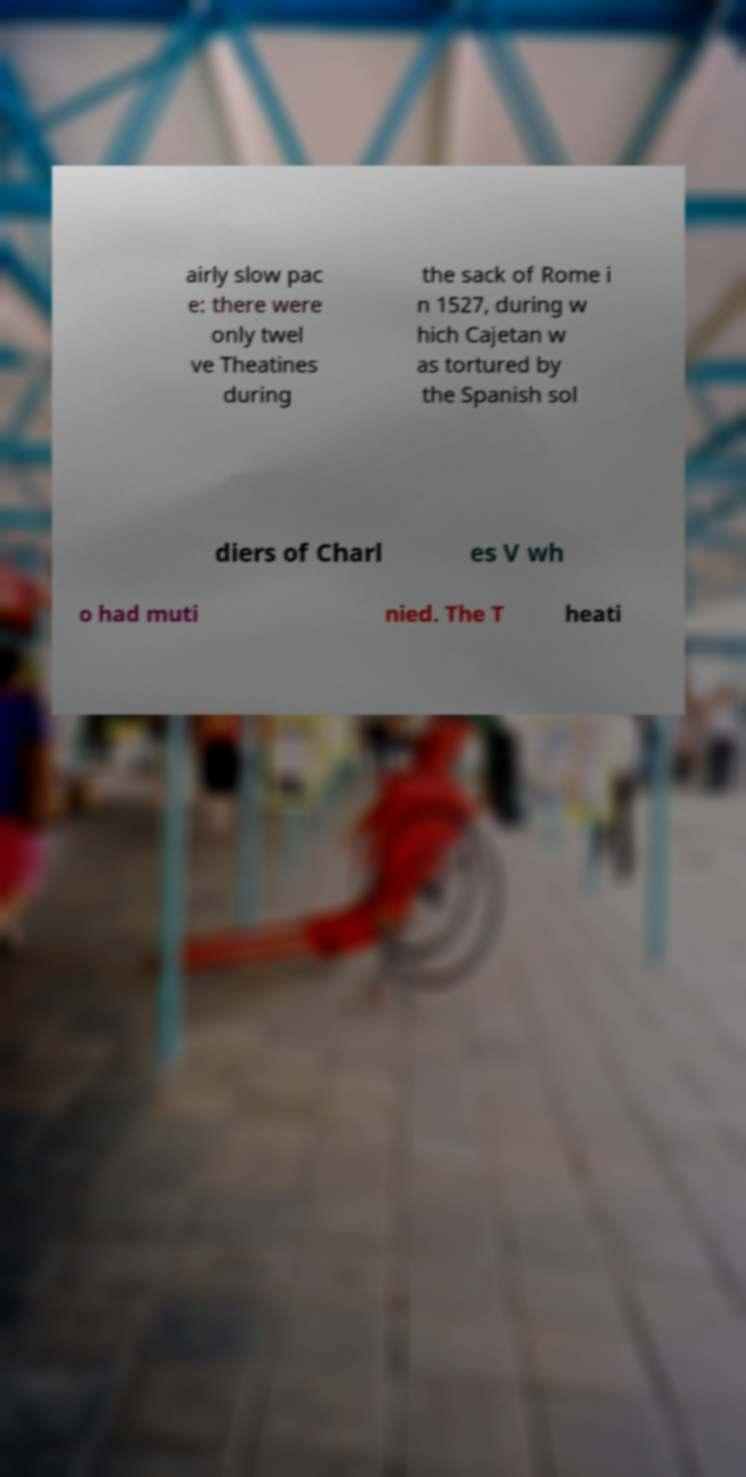Could you assist in decoding the text presented in this image and type it out clearly? airly slow pac e: there were only twel ve Theatines during the sack of Rome i n 1527, during w hich Cajetan w as tortured by the Spanish sol diers of Charl es V wh o had muti nied. The T heati 